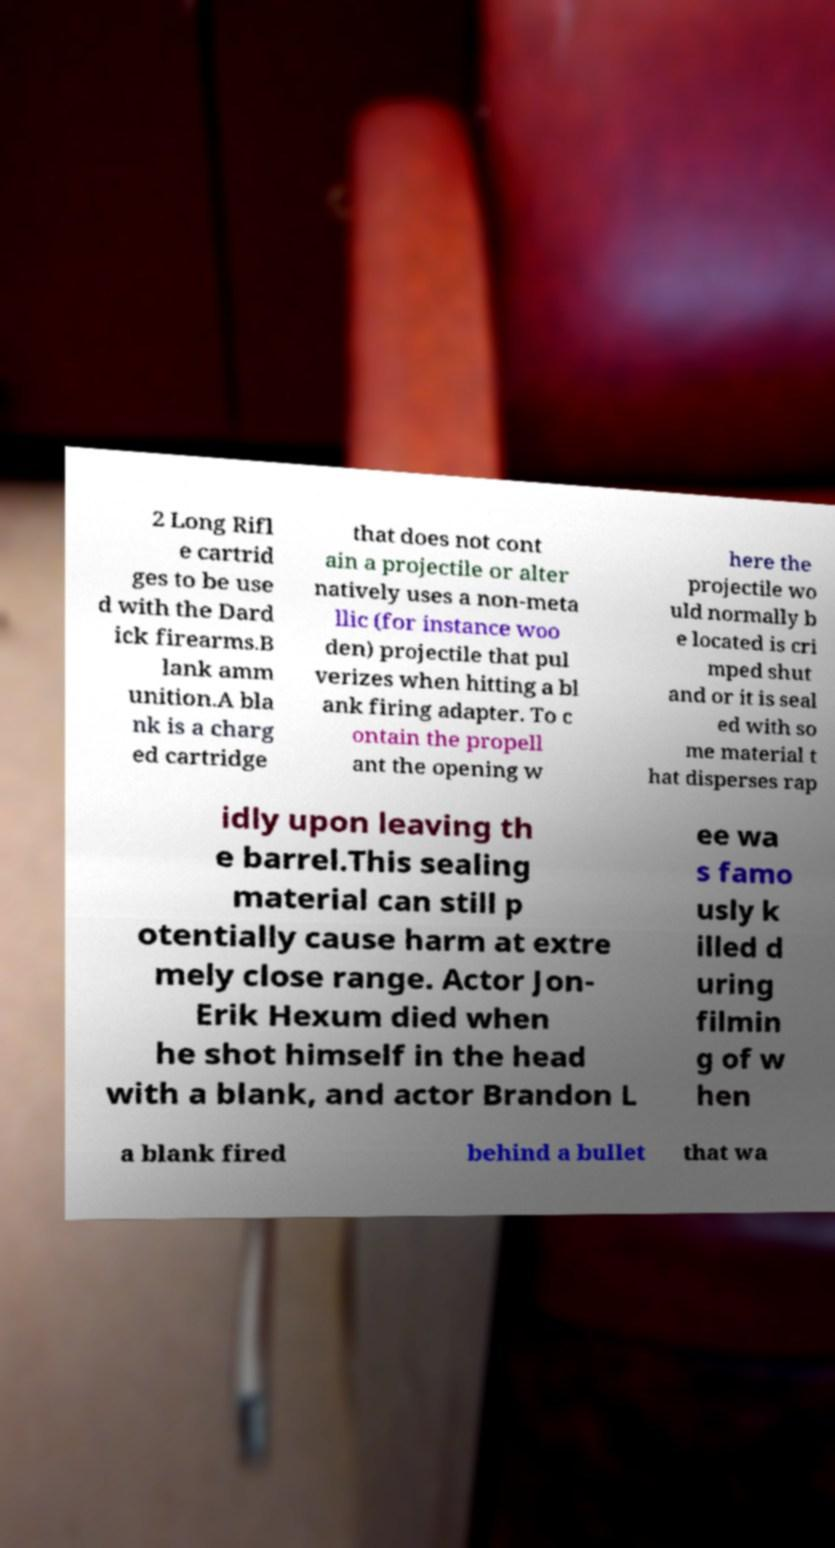For documentation purposes, I need the text within this image transcribed. Could you provide that? 2 Long Rifl e cartrid ges to be use d with the Dard ick firearms.B lank amm unition.A bla nk is a charg ed cartridge that does not cont ain a projectile or alter natively uses a non-meta llic (for instance woo den) projectile that pul verizes when hitting a bl ank firing adapter. To c ontain the propell ant the opening w here the projectile wo uld normally b e located is cri mped shut and or it is seal ed with so me material t hat disperses rap idly upon leaving th e barrel.This sealing material can still p otentially cause harm at extre mely close range. Actor Jon- Erik Hexum died when he shot himself in the head with a blank, and actor Brandon L ee wa s famo usly k illed d uring filmin g of w hen a blank fired behind a bullet that wa 